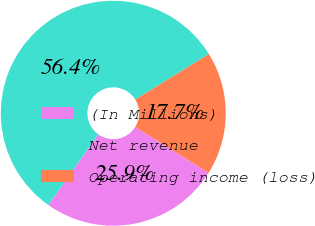Convert chart to OTSL. <chart><loc_0><loc_0><loc_500><loc_500><pie_chart><fcel>(In Millions)<fcel>Net revenue<fcel>Operating income (loss)<nl><fcel>25.9%<fcel>56.37%<fcel>17.73%<nl></chart> 